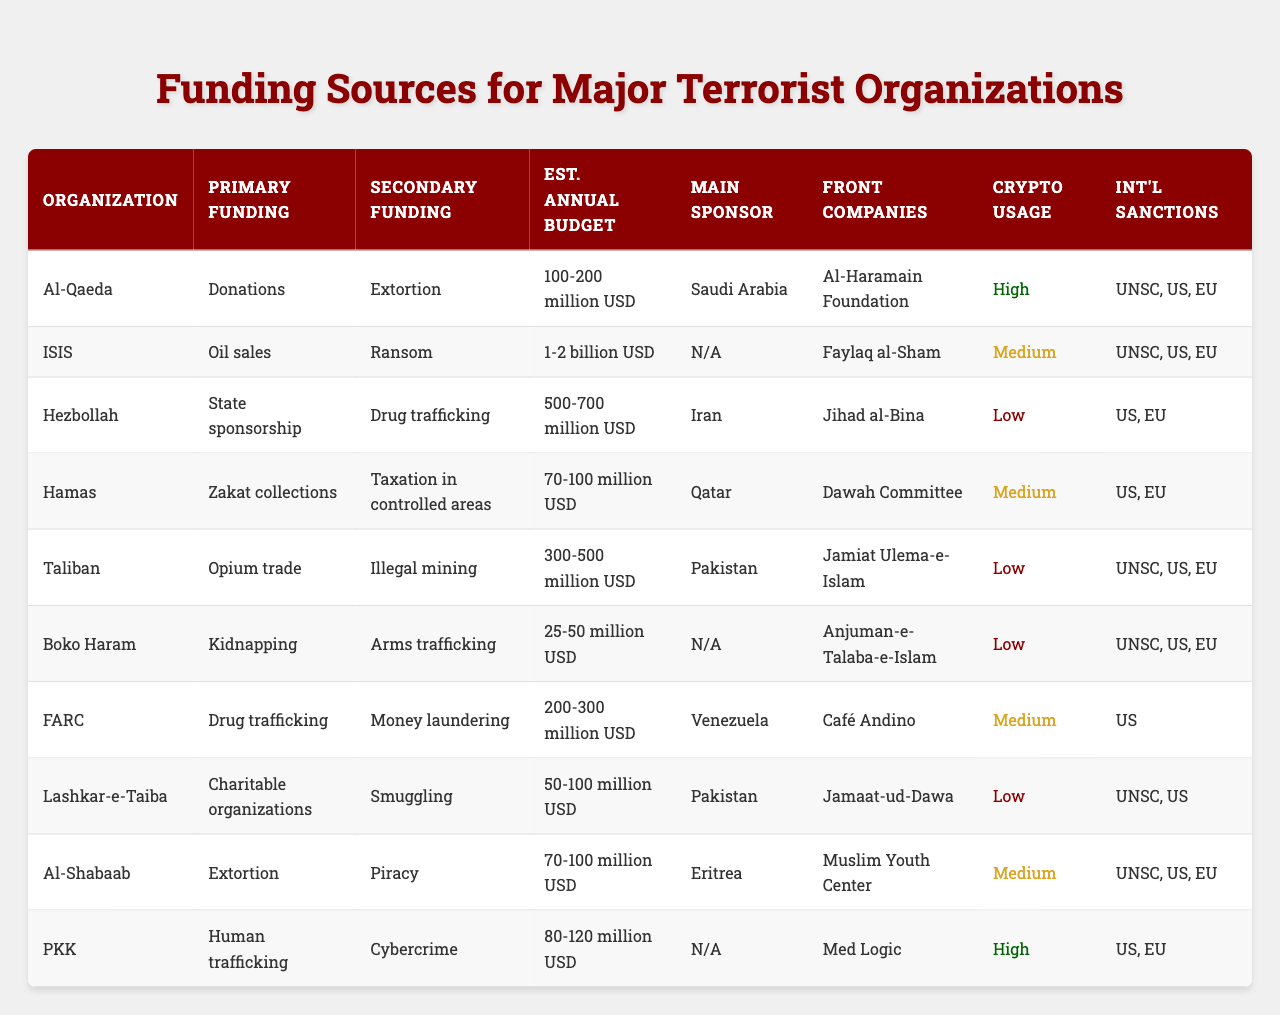What is the primary funding source for Hezbollah? Referring to the table, Hezbollah's primary funding source is listed as "State sponsorship."
Answer: State sponsorship Which terrorist organization has the highest estimated annual budget? The table shows that ISIS has the highest estimated annual budget of "1-2 billion USD."
Answer: 1-2 billion USD What funding method is common for both Al-Qaeda and Hamas? Both organizations rely on "Zakat collections" as a primary funding source and have "Extortion" as a secondary funding source.
Answer: Zakat collections True or False: Boko Haram has a primary funding source of opium trade. The table lists Boko Haram's primary funding source as "Kidnapping," not opium trade.
Answer: False What is the secondary funding source for the Taliban? According to the table, the Taliban's secondary funding source is "Taxation in controlled areas."
Answer: Taxation in controlled areas Which organization uses cryptocurrency the most? The table categorizes Al-Qaeda and PKK as having "High" cryptocurrency usage compared to others.
Answer: Al-Qaeda and PKK What is the total estimated annual budget of Al-Shabaab and Hamas combined? Al-Shabaab has an estimated annual budget of "70-100 million USD" and Hamas has "70-100 million USD." Adding these ranges (70+70 and 100+100) gives 140-200 million USD.
Answer: 140-200 million USD Which organization's main sponsoring country is Pakistan, and what is its primary funding source? The table indicates that Lashkar-e-Taiba is sponsored by Pakistan and its primary funding source is "Charitable organizations."
Answer: Lashkar-e-Taiba; Charitable organizations Is drug trafficking a funding source for more than three organizations listed in the table? By reviewing the table, drug trafficking is noted as a secondary funding source for FARC, Boko Haram, and as a funding mechanism for ISIS, confirming it is utilized by more than three organizations total.
Answer: Yes What is the relationship between FARC's primary funding source and its estimated annual budget? The table shows that FARC's primary funding source is "Drug trafficking," and its estimated annual budget is "200-300 million USD." This indicates that FARC operates with relatively significant financial resources linked to drug trafficking.
Answer: Drug trafficking; 200-300 million USD 